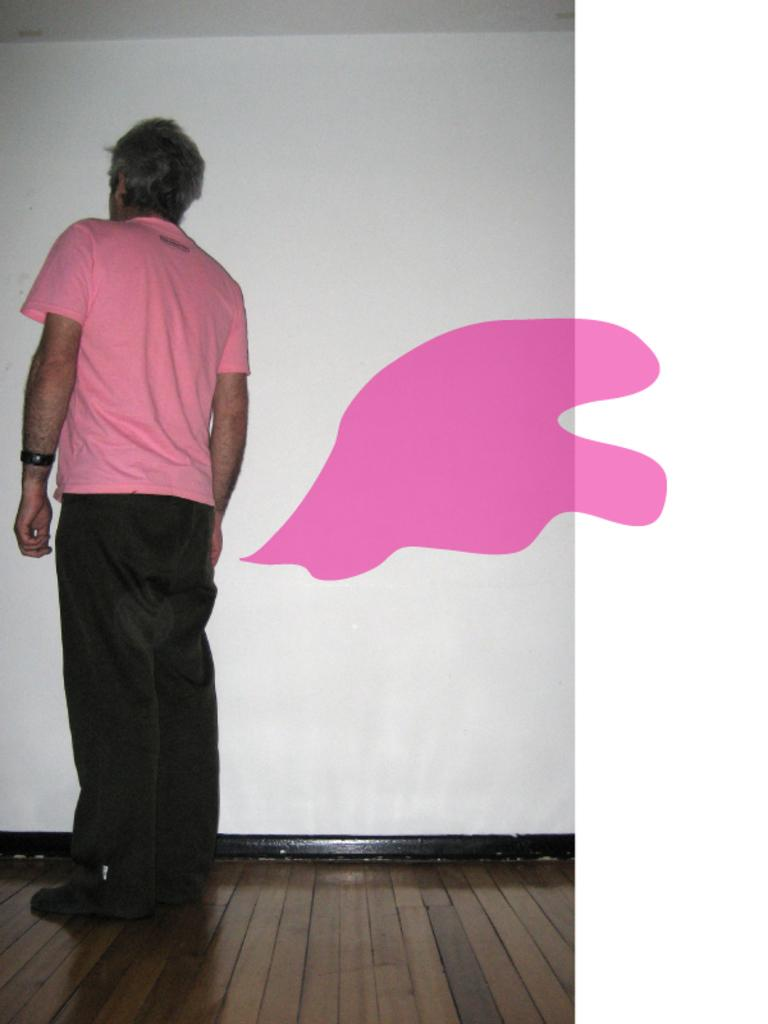What is the main subject of the image? There is a man standing in the image. What color can be seen in the image? The color pink is present in the image. What is visible in the background of the image? There is a white wall in the background of the image. What type of fruit is being peeled on the curve of the white wall in the image? There is no fruit or any indication of peeling in the image. 